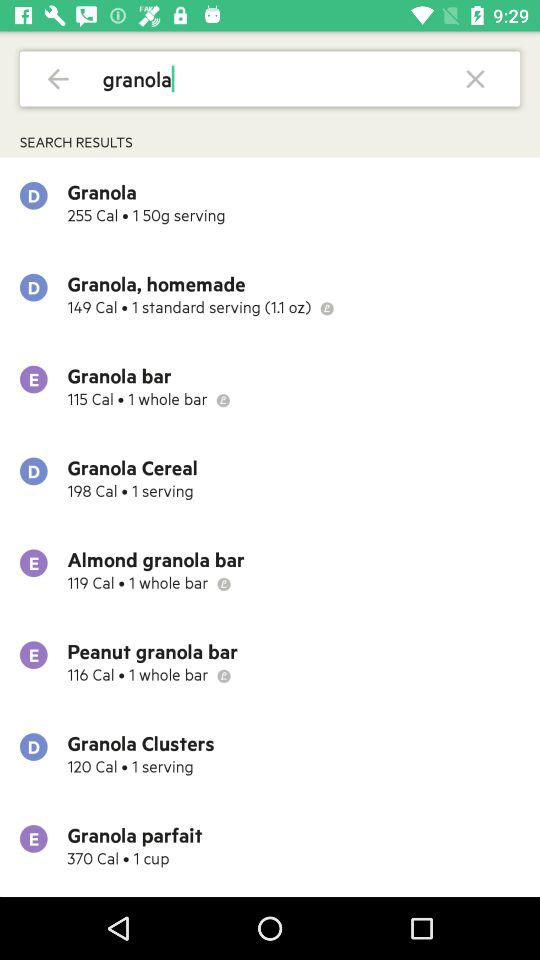What is the serving size of the granola? The serving size is 150 grams. 